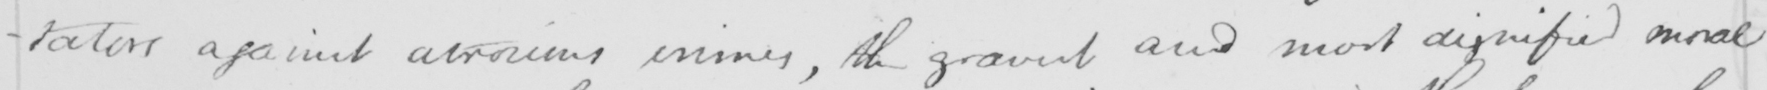Transcribe the text shown in this historical manuscript line. -tators against atrocious crimes , the gravest and most dignified moral 